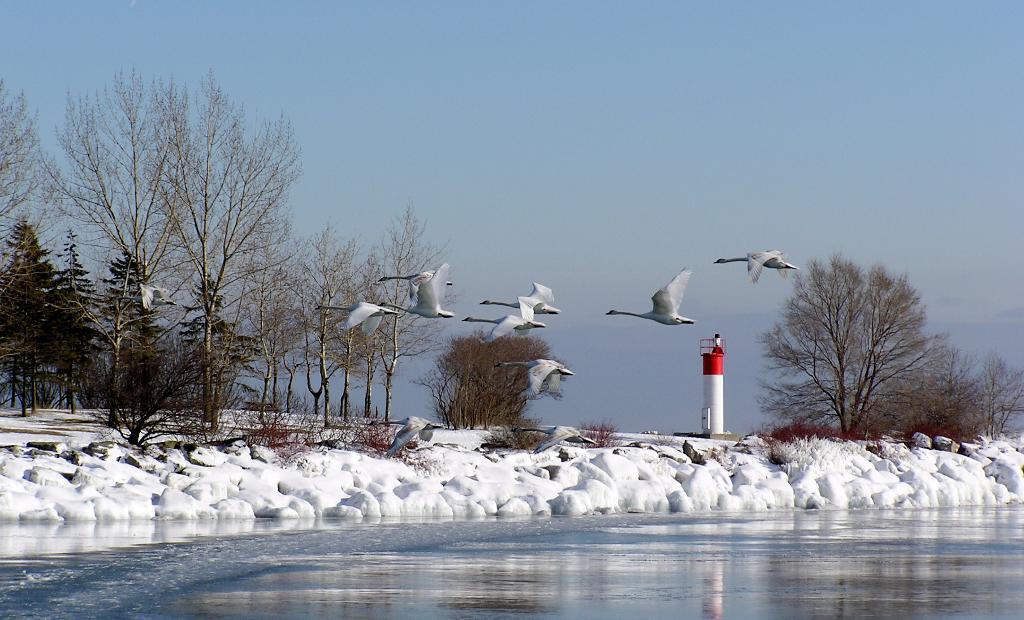Describe this image in one or two sentences. In the center of the image we can see a group of birds flying in the sky. In the foreground we can see a lake with water. In the background, we can see a group of trees, a lighthouse and the sky. 